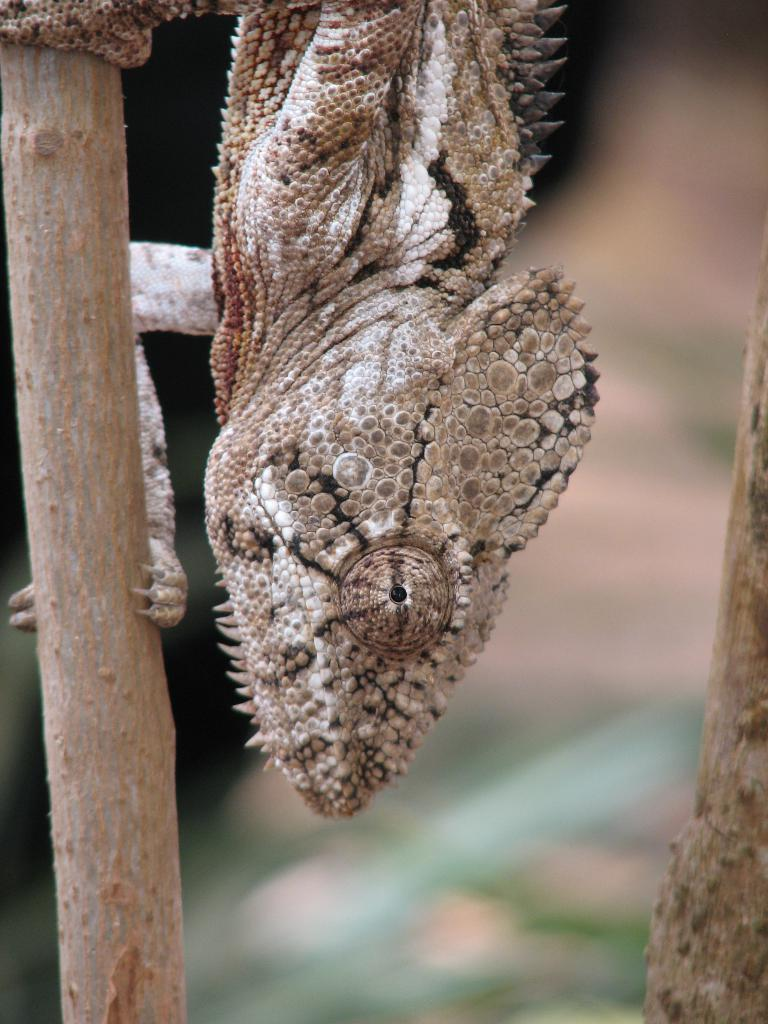What type of animal is in the picture? There is a reptile in the picture. Where is the reptile located? The reptile is on a stem. Can you describe the background of the image? The background of the image is blurry. What color is the approval in the image? There is no approval present in the image, as it is a picture of a reptile on a stem with a blurry background. 